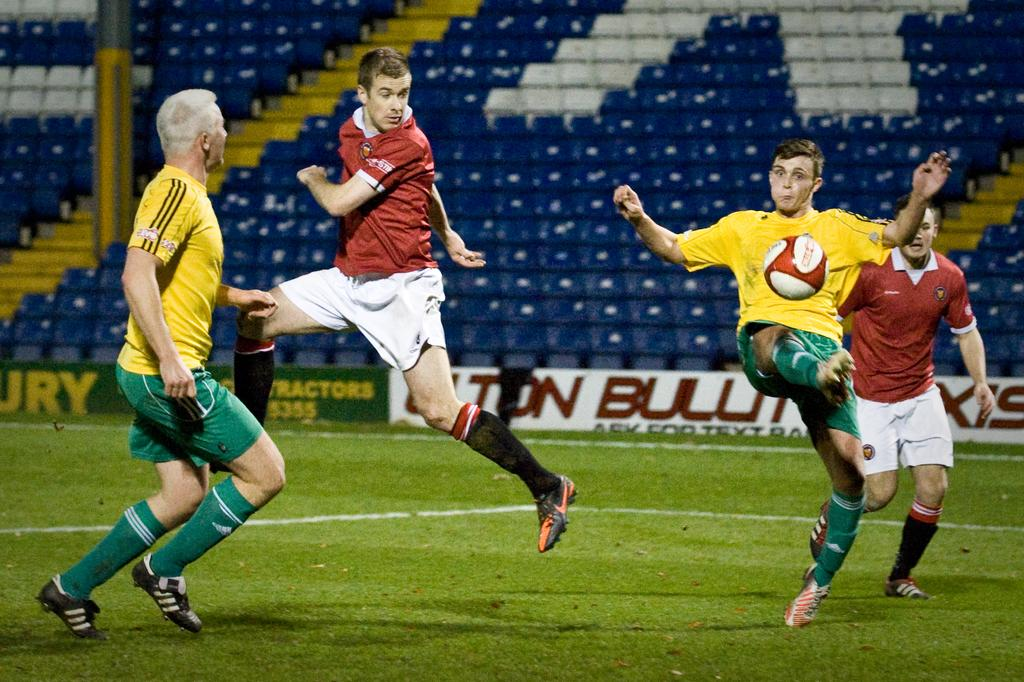<image>
Provide a brief description of the given image. Several players make a play for the ball during a soccer game where Tractors are advertised on a green side board. 